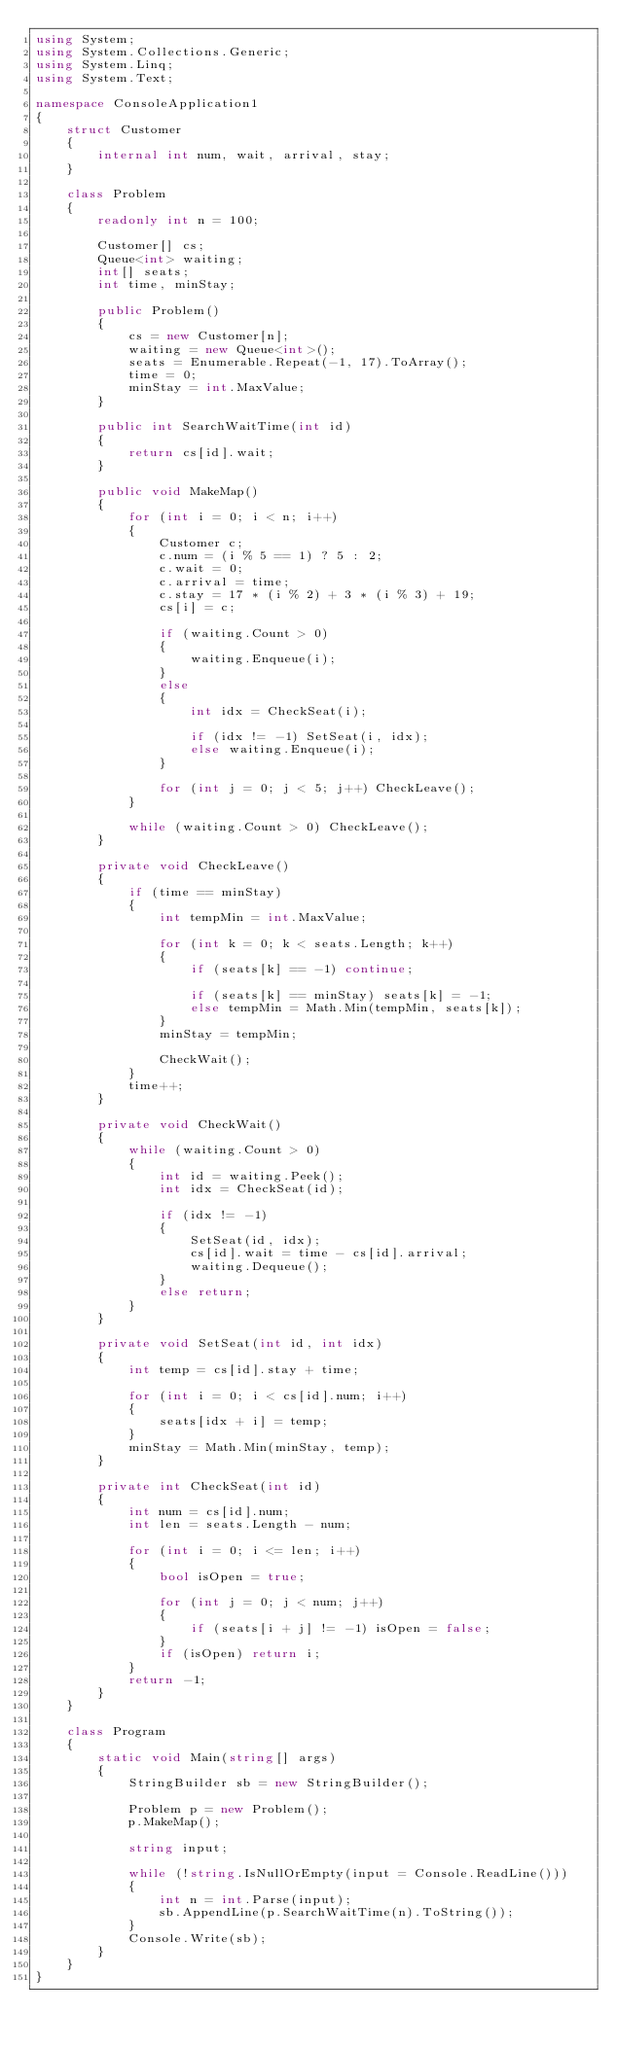Convert code to text. <code><loc_0><loc_0><loc_500><loc_500><_C#_>using System;
using System.Collections.Generic;
using System.Linq;
using System.Text;

namespace ConsoleApplication1
{
    struct Customer
    {
        internal int num, wait, arrival, stay;
    }

    class Problem
    {
        readonly int n = 100;

        Customer[] cs;
        Queue<int> waiting;
        int[] seats;
        int time, minStay;

        public Problem()
        {
            cs = new Customer[n];
            waiting = new Queue<int>();
            seats = Enumerable.Repeat(-1, 17).ToArray();
            time = 0;
            minStay = int.MaxValue;
        }

        public int SearchWaitTime(int id)
        {
            return cs[id].wait;
        }

        public void MakeMap()
        {
            for (int i = 0; i < n; i++)
            {
                Customer c;
                c.num = (i % 5 == 1) ? 5 : 2;
                c.wait = 0;
                c.arrival = time;
                c.stay = 17 * (i % 2) + 3 * (i % 3) + 19;
                cs[i] = c;

                if (waiting.Count > 0)
                {
                    waiting.Enqueue(i);
                }
                else
                {
                    int idx = CheckSeat(i);

                    if (idx != -1) SetSeat(i, idx);
                    else waiting.Enqueue(i);
                }

                for (int j = 0; j < 5; j++) CheckLeave();
            }

            while (waiting.Count > 0) CheckLeave();
        }

        private void CheckLeave()
        {
            if (time == minStay)
            {
                int tempMin = int.MaxValue;

                for (int k = 0; k < seats.Length; k++)
                {
                    if (seats[k] == -1) continue;

                    if (seats[k] == minStay) seats[k] = -1;
                    else tempMin = Math.Min(tempMin, seats[k]);
                }
                minStay = tempMin;

                CheckWait();
            }
            time++;
        }

        private void CheckWait()
        {
            while (waiting.Count > 0)
            {
                int id = waiting.Peek();
                int idx = CheckSeat(id);

                if (idx != -1)
                {
                    SetSeat(id, idx);
                    cs[id].wait = time - cs[id].arrival;
                    waiting.Dequeue();
                }
                else return;
            }
        }

        private void SetSeat(int id, int idx)
        {
            int temp = cs[id].stay + time;

            for (int i = 0; i < cs[id].num; i++)
            {
                seats[idx + i] = temp;
            }
            minStay = Math.Min(minStay, temp);
        }

        private int CheckSeat(int id)
        {
            int num = cs[id].num;
            int len = seats.Length - num;

            for (int i = 0; i <= len; i++)
            {
                bool isOpen = true;

                for (int j = 0; j < num; j++)
                {
                    if (seats[i + j] != -1) isOpen = false;
                }
                if (isOpen) return i;
            }
            return -1;
        }
    }

    class Program
    {
        static void Main(string[] args)
        {
            StringBuilder sb = new StringBuilder();

            Problem p = new Problem();
            p.MakeMap();

            string input;

            while (!string.IsNullOrEmpty(input = Console.ReadLine()))
            {
                int n = int.Parse(input);
                sb.AppendLine(p.SearchWaitTime(n).ToString());
            }
            Console.Write(sb);
        }
    }
}</code> 